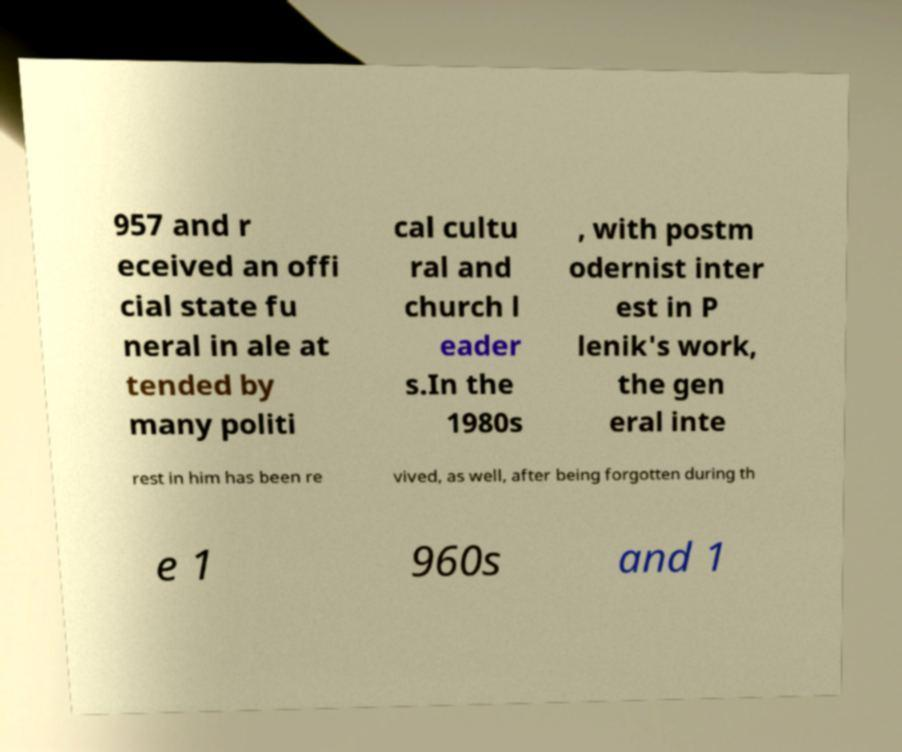I need the written content from this picture converted into text. Can you do that? 957 and r eceived an offi cial state fu neral in ale at tended by many politi cal cultu ral and church l eader s.In the 1980s , with postm odernist inter est in P lenik's work, the gen eral inte rest in him has been re vived, as well, after being forgotten during th e 1 960s and 1 